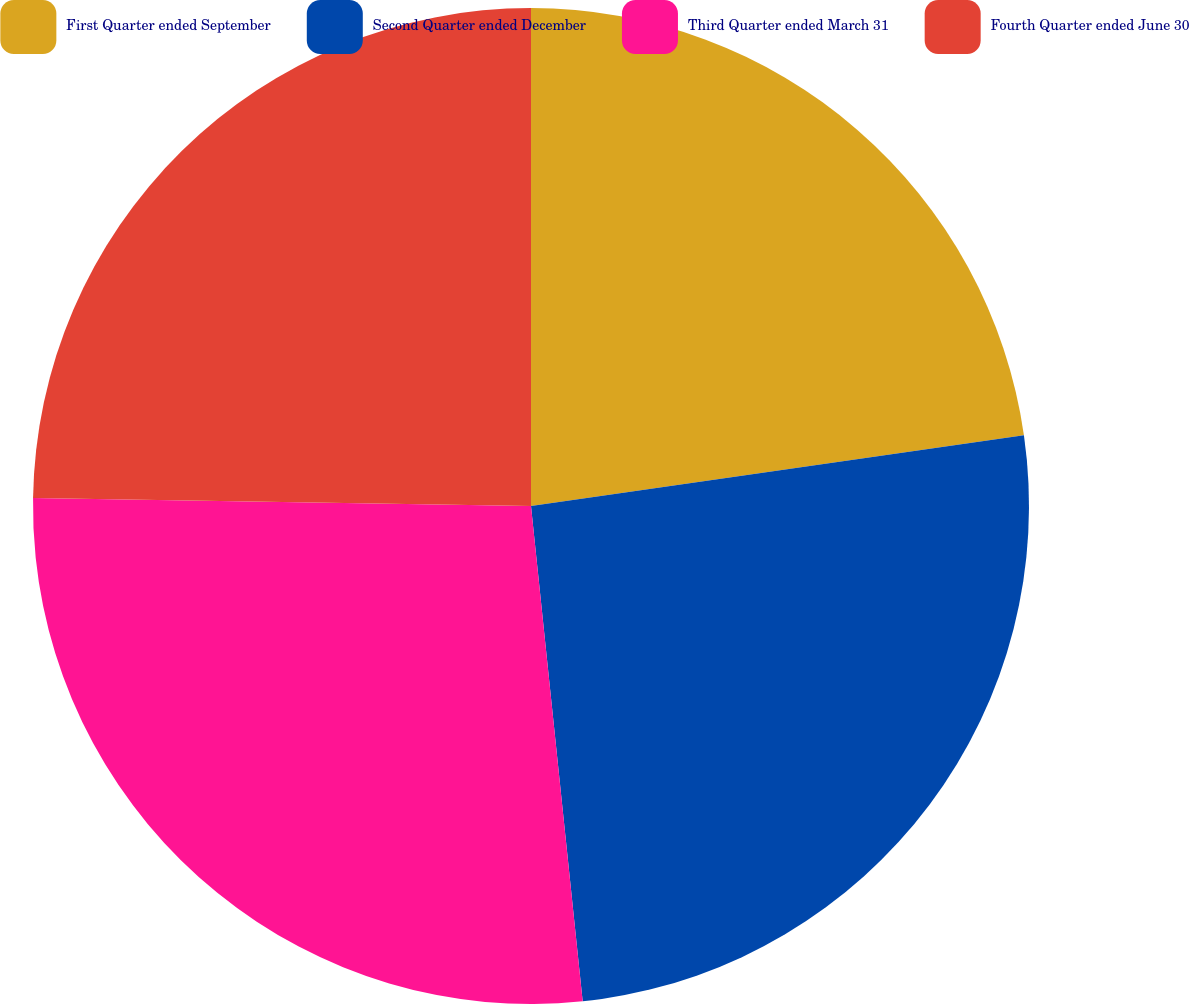Convert chart to OTSL. <chart><loc_0><loc_0><loc_500><loc_500><pie_chart><fcel>First Quarter ended September<fcel>Second Quarter ended December<fcel>Third Quarter ended March 31<fcel>Fourth Quarter ended June 30<nl><fcel>22.73%<fcel>25.62%<fcel>26.91%<fcel>24.75%<nl></chart> 